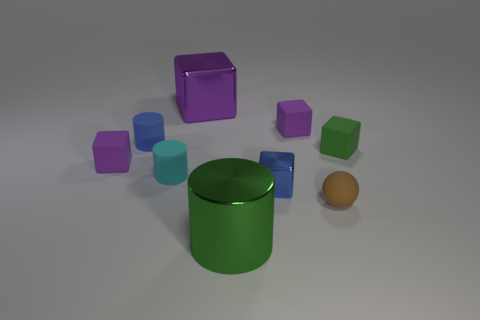There is a tiny purple cube behind the small purple cube in front of the tiny green matte object; how many brown things are to the right of it?
Offer a very short reply. 1. Is there a green shiny cylinder of the same size as the green matte object?
Give a very brief answer. No. Is the number of small brown spheres in front of the green metallic thing less than the number of big gray matte spheres?
Give a very brief answer. No. What material is the purple thing that is right of the metallic cube behind the cylinder behind the green cube?
Make the answer very short. Rubber. Are there more blocks on the left side of the tiny metallic thing than purple cubes that are to the right of the purple metal thing?
Keep it short and to the point. Yes. What number of rubber objects are big green cylinders or small blue objects?
Give a very brief answer. 1. The rubber thing that is the same color as the small shiny cube is what shape?
Make the answer very short. Cylinder. What material is the small blue object right of the large purple shiny cube?
Your answer should be compact. Metal. What number of things are large objects or tiny things that are in front of the tiny green block?
Your response must be concise. 6. What shape is the brown object that is the same size as the blue rubber cylinder?
Your answer should be compact. Sphere. 